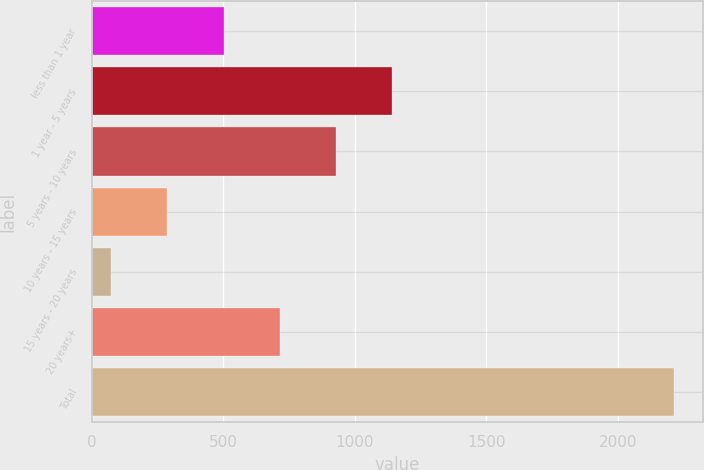Convert chart to OTSL. <chart><loc_0><loc_0><loc_500><loc_500><bar_chart><fcel>less than 1 year<fcel>1 year - 5 years<fcel>5 years - 10 years<fcel>10 years - 15 years<fcel>15 years - 20 years<fcel>20 years+<fcel>Total<nl><fcel>501<fcel>1143<fcel>929<fcel>287<fcel>73<fcel>715<fcel>2213<nl></chart> 